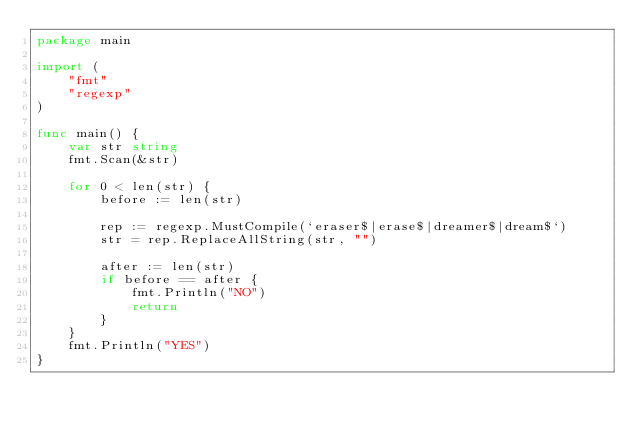<code> <loc_0><loc_0><loc_500><loc_500><_Go_>package main

import (
	"fmt"
	"regexp"
)

func main() {
	var str string
	fmt.Scan(&str)

	for 0 < len(str) {
		before := len(str)

		rep := regexp.MustCompile(`eraser$|erase$|dreamer$|dream$`)
		str = rep.ReplaceAllString(str, "")

		after := len(str)
		if before == after {
			fmt.Println("NO")
			return
		}
	}
	fmt.Println("YES")
}
</code> 